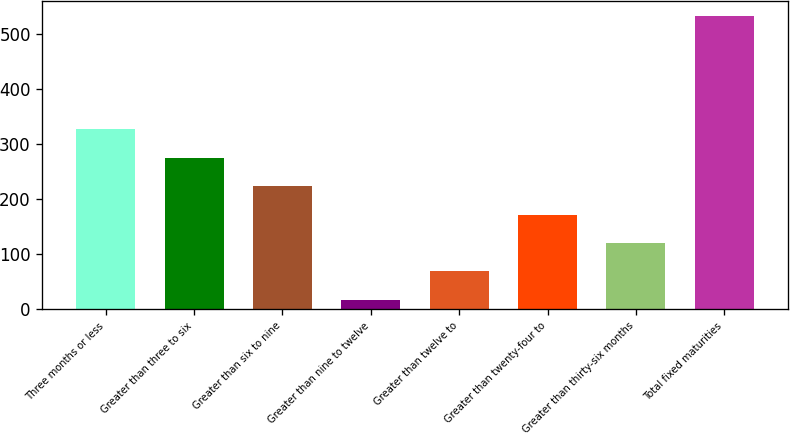Convert chart. <chart><loc_0><loc_0><loc_500><loc_500><bar_chart><fcel>Three months or less<fcel>Greater than three to six<fcel>Greater than six to nine<fcel>Greater than nine to twelve<fcel>Greater than twelve to<fcel>Greater than twenty-four to<fcel>Greater than thirty-six months<fcel>Total fixed maturities<nl><fcel>326.36<fcel>274.85<fcel>223.34<fcel>17.3<fcel>68.81<fcel>171.83<fcel>120.32<fcel>532.4<nl></chart> 